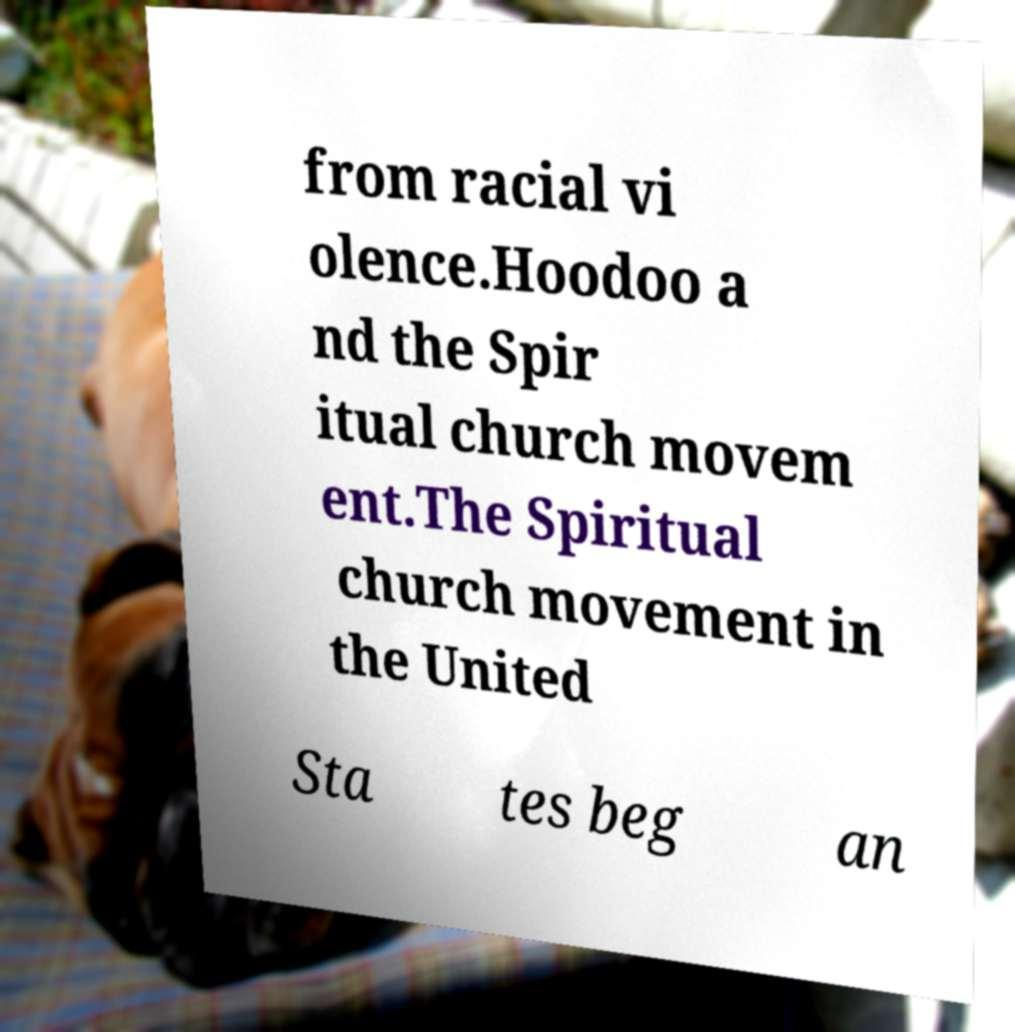Could you assist in decoding the text presented in this image and type it out clearly? from racial vi olence.Hoodoo a nd the Spir itual church movem ent.The Spiritual church movement in the United Sta tes beg an 